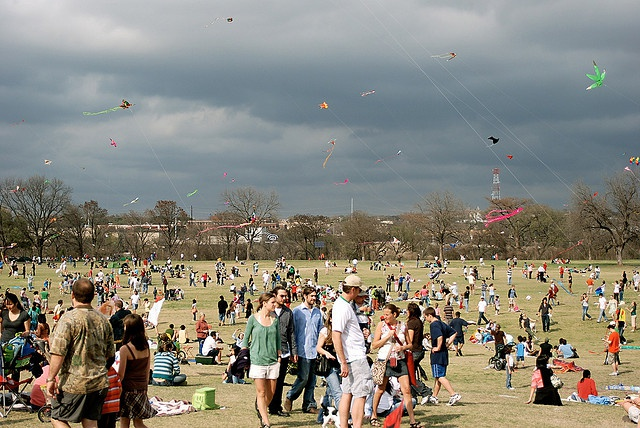Describe the objects in this image and their specific colors. I can see people in lightgray, tan, and black tones, people in lightgray, black, gray, tan, and maroon tones, kite in lightgray, gray, and darkgray tones, people in lightgray, darkgray, and tan tones, and people in lightgray, black, darkgray, ivory, and tan tones in this image. 